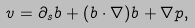<formula> <loc_0><loc_0><loc_500><loc_500>v = \partial _ { s } b + ( b \cdot \nabla ) b + \nabla p ,</formula> 